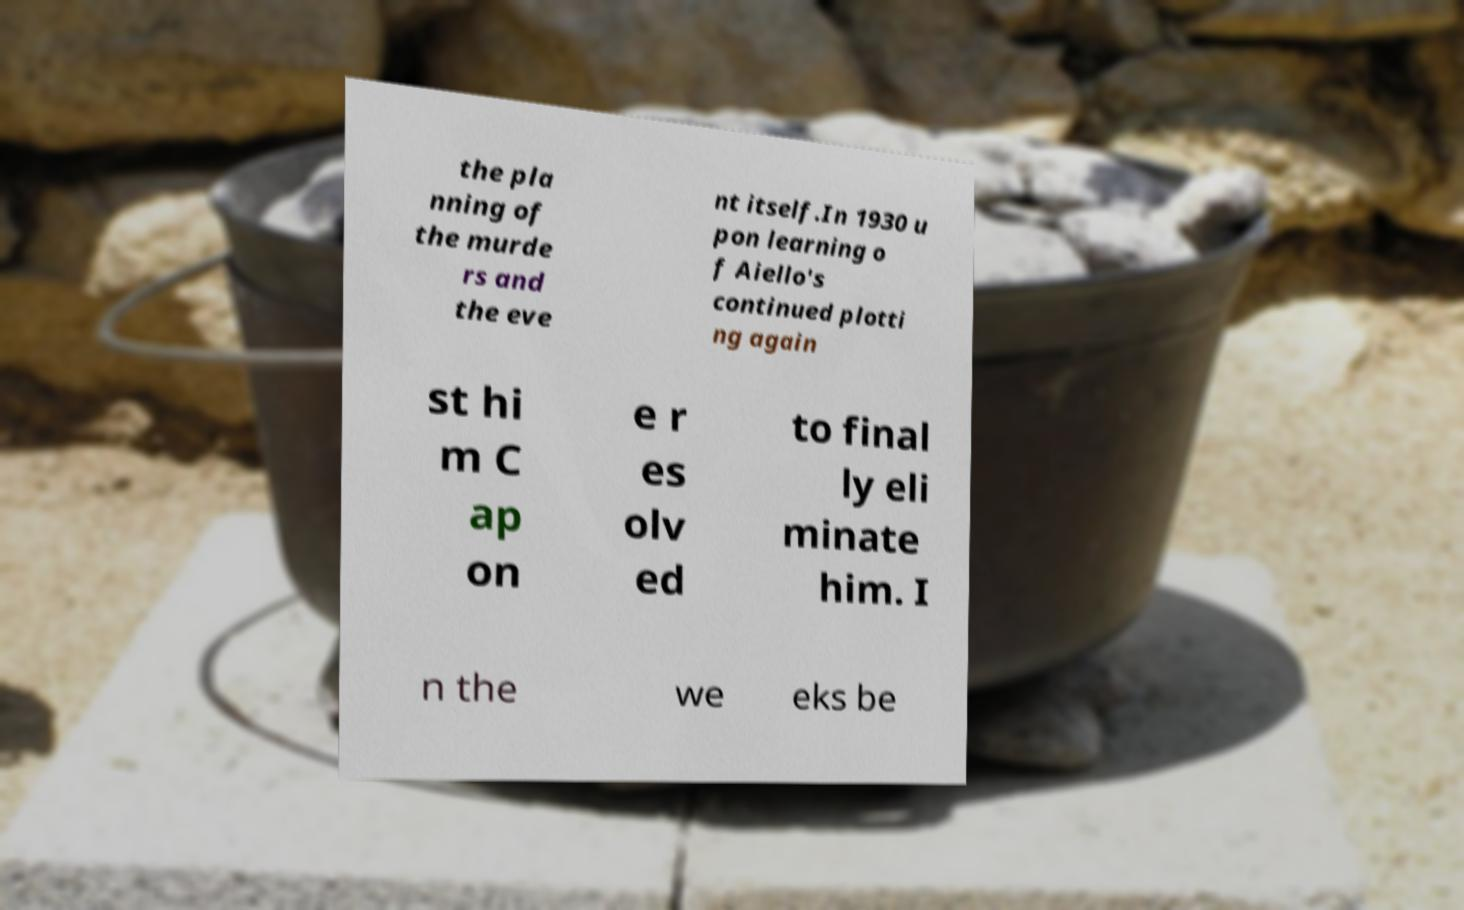I need the written content from this picture converted into text. Can you do that? the pla nning of the murde rs and the eve nt itself.In 1930 u pon learning o f Aiello's continued plotti ng again st hi m C ap on e r es olv ed to final ly eli minate him. I n the we eks be 